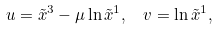Convert formula to latex. <formula><loc_0><loc_0><loc_500><loc_500>u = \tilde { x } ^ { 3 } - \mu \ln \tilde { x } ^ { 1 } , \ \ v = \ln \tilde { x } ^ { 1 } ,</formula> 